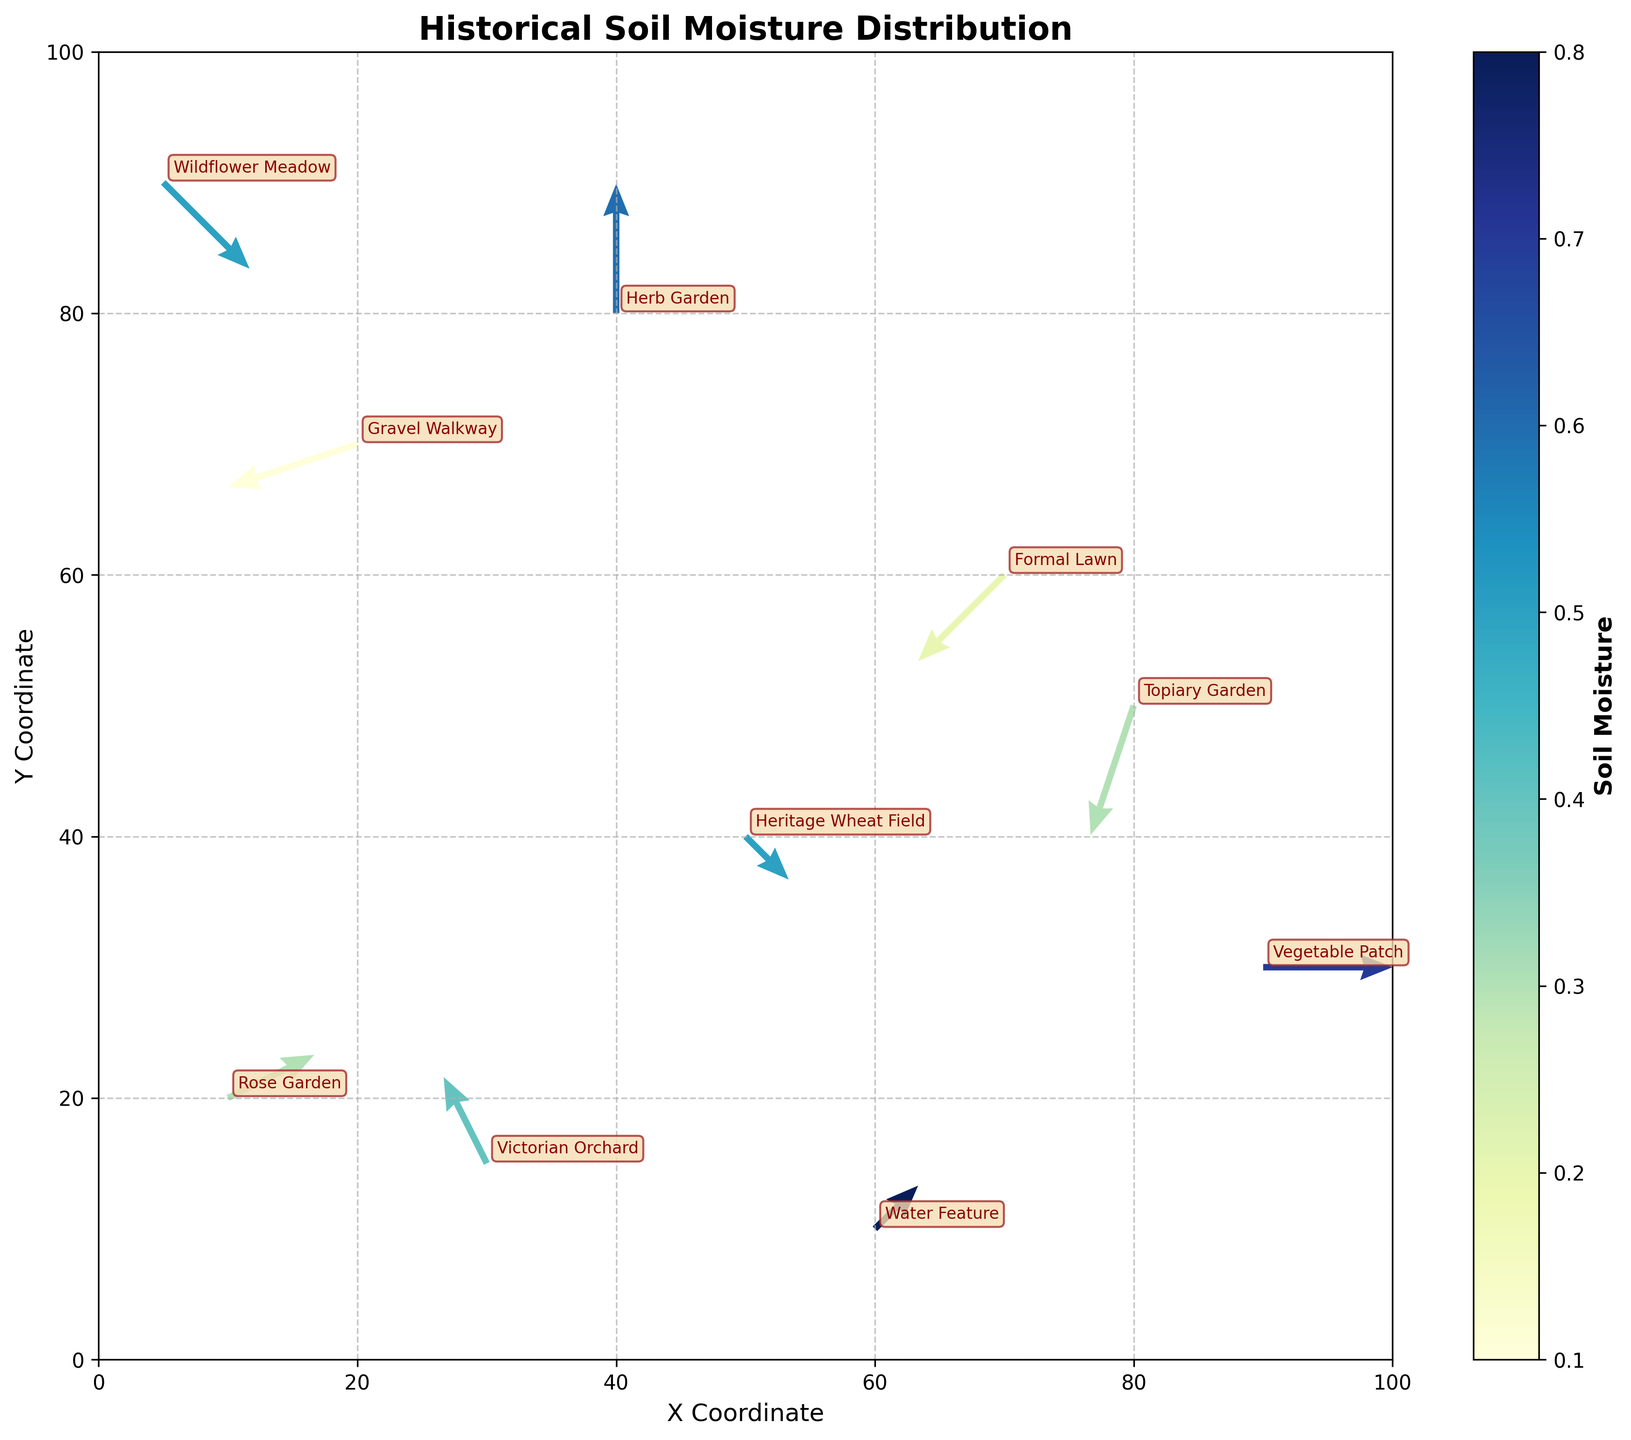What is the title of the plot? The title is displayed at the top of the plot. It reads "Historical Soil Moisture Distribution".
Answer: Historical Soil Moisture Distribution What does the color bar indicate? The color bar provides a scale for interpreting the soil moisture levels, labeled as "Soil Moisture". Darker blues represent higher moisture, while lighter yellows indicate lower moisture levels.
Answer: Soil moisture levels Which area has the highest soil moisture? By observing the colors associated with each area, the "Vegetable Patch" has the darkest blue color in the plot, indicating the highest soil moisture.
Answer: Vegetable Patch What is the average soil moisture of the areas labeled "Rose Garden", "Victorian Orchard", and "Heritage Wheat Field"? The moisture values for these areas are 0.3, 0.4, and 0.5 respectively. The average can be calculated as (0.3 + 0.4 + 0.5) / 3 = 1.2 / 3 = 0.4
Answer: 0.4 How does the soil moisture in the "Topiary Garden" compare to the "Gravel Walkway"? "Topiary Garden" has a soil moisture of 0.3 and "Gravel Walkway" has 0.1. 0.3 is greater than 0.1.
Answer: Topiary Garden has higher moisture Which area has the largest resultant vector magnitude and what is it? Calculate the vector magnitudes for each area using √(U^2 + V^2). For "Herb Garden", the magnitude is √(0^2 + 3^2) = 3, which is the largest compared to others like "Rose Garden" (√(2^2 + 1^2) ≈ 2.24).
Answer: Herb Garden with magnitude 3 What directions are the vectors pointing in the "Formal Lawn" and "Water Feature"? The "Formal Lawn" vector has U=-2 and V=-2, indicating it's pointing south-west. The "Water Feature" vector has U=1 and V=1, indicating it's pointing north-east.
Answer: Formal Lawn: south-west, Water Feature: north-east In which quadrant is "Wildflower Meadow" located? The coordinates of "Wildflower Meadow" are (5, 90). Since X is positive and Y is positive, it lies in the first quadrant.
Answer: First quadrant Are there any areas whose vectors point straight vertically upward? Vectors pointing straight up will have U=0 and V>0. The "Herb Garden" has U=0 and V=3, thus pointing vertically upward.
Answer: Herb Garden Which areas have soil moisture levels below 0.2? The areas with soil moisture < 0.2 are indicated by their color on the plot. "Gravel Walkway" with 0.1 is such an area.
Answer: Gravel Walkway 